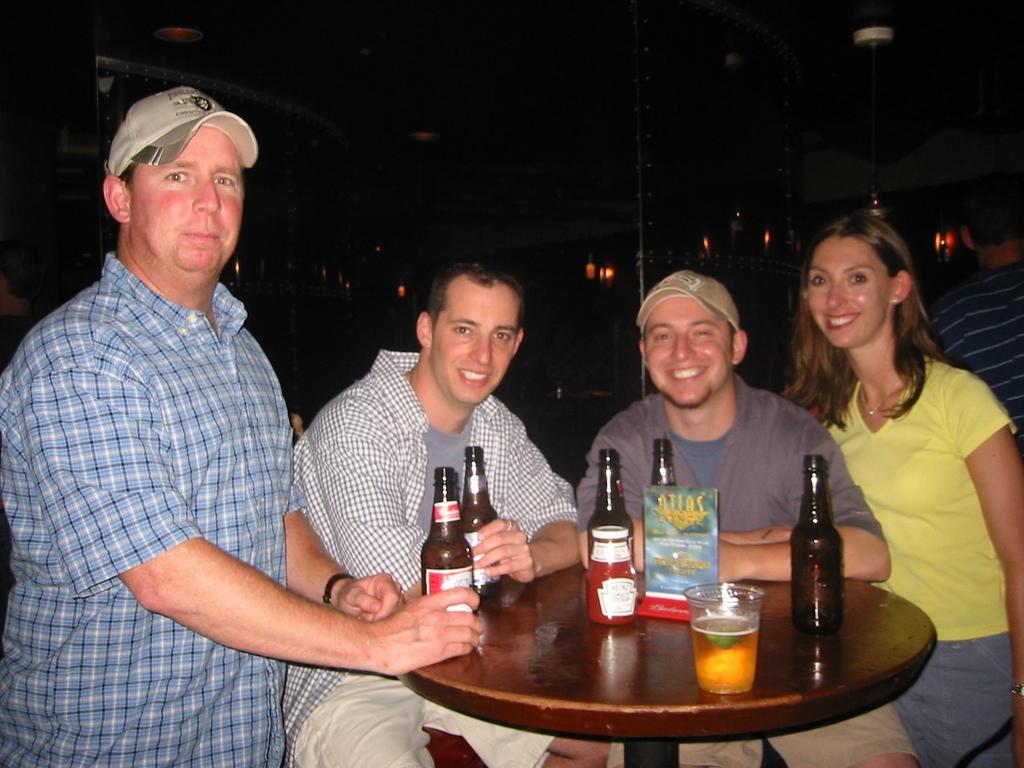Could you give a brief overview of what you see in this image? In this picture, we see three people sitting on chair around the table on which five alcohol bottles, a glass containing wine and book are placed on the table and all the three of them are smiling. Behind the, man in blue check shirt who is wearing white cap is standing near the table. 